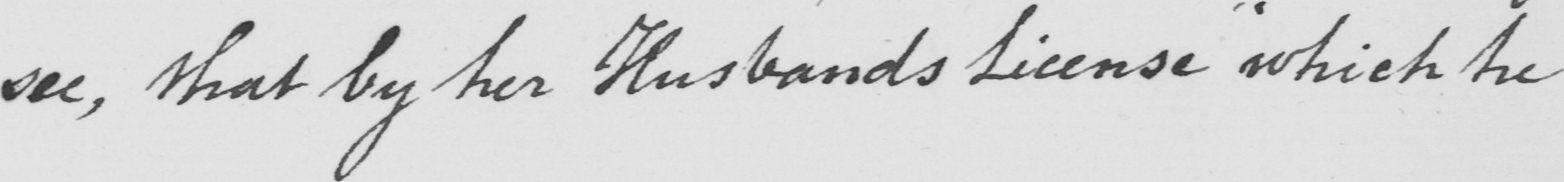Can you read and transcribe this handwriting? see, that by her Husbands License "which he 